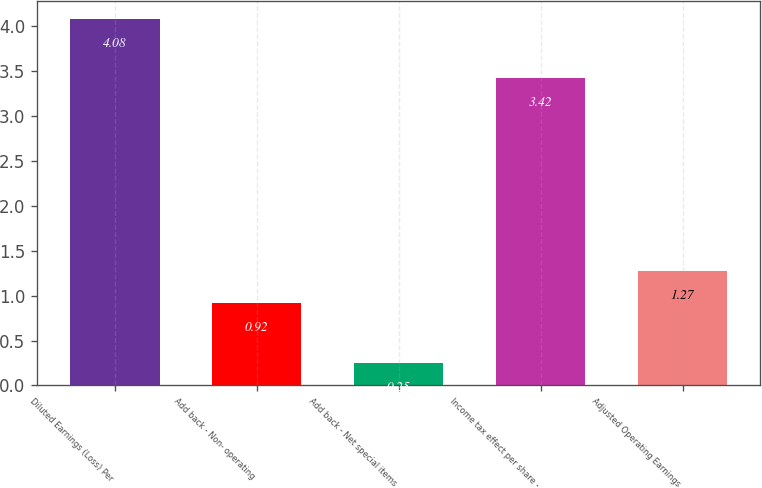<chart> <loc_0><loc_0><loc_500><loc_500><bar_chart><fcel>Diluted Earnings (Loss) Per<fcel>Add back - Non- operating<fcel>Add back - Net special items<fcel>Income tax effect per share -<fcel>Adjusted Operating Earnings<nl><fcel>4.08<fcel>0.92<fcel>0.25<fcel>3.42<fcel>1.27<nl></chart> 